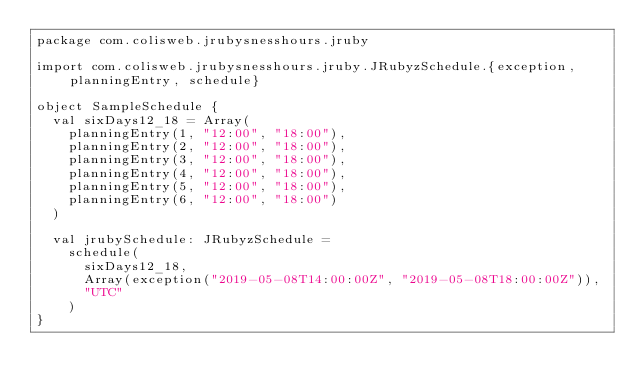Convert code to text. <code><loc_0><loc_0><loc_500><loc_500><_Scala_>package com.colisweb.jrubysnesshours.jruby

import com.colisweb.jrubysnesshours.jruby.JRubyzSchedule.{exception, planningEntry, schedule}

object SampleSchedule {
  val sixDays12_18 = Array(
    planningEntry(1, "12:00", "18:00"),
    planningEntry(2, "12:00", "18:00"),
    planningEntry(3, "12:00", "18:00"),
    planningEntry(4, "12:00", "18:00"),
    planningEntry(5, "12:00", "18:00"),
    planningEntry(6, "12:00", "18:00")
  )

  val jrubySchedule: JRubyzSchedule =
    schedule(
      sixDays12_18,
      Array(exception("2019-05-08T14:00:00Z", "2019-05-08T18:00:00Z")),
      "UTC"
    )
}
</code> 